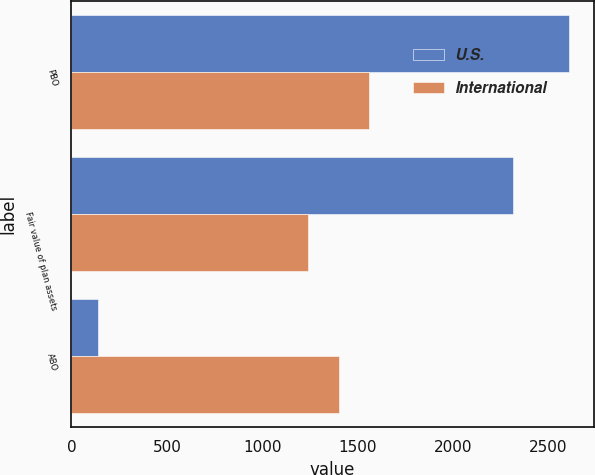<chart> <loc_0><loc_0><loc_500><loc_500><stacked_bar_chart><ecel><fcel>PBO<fcel>Fair value of plan assets<fcel>ABO<nl><fcel>U.S.<fcel>2607.6<fcel>2313.4<fcel>139.3<nl><fcel>International<fcel>1558.7<fcel>1239.4<fcel>1401.3<nl></chart> 